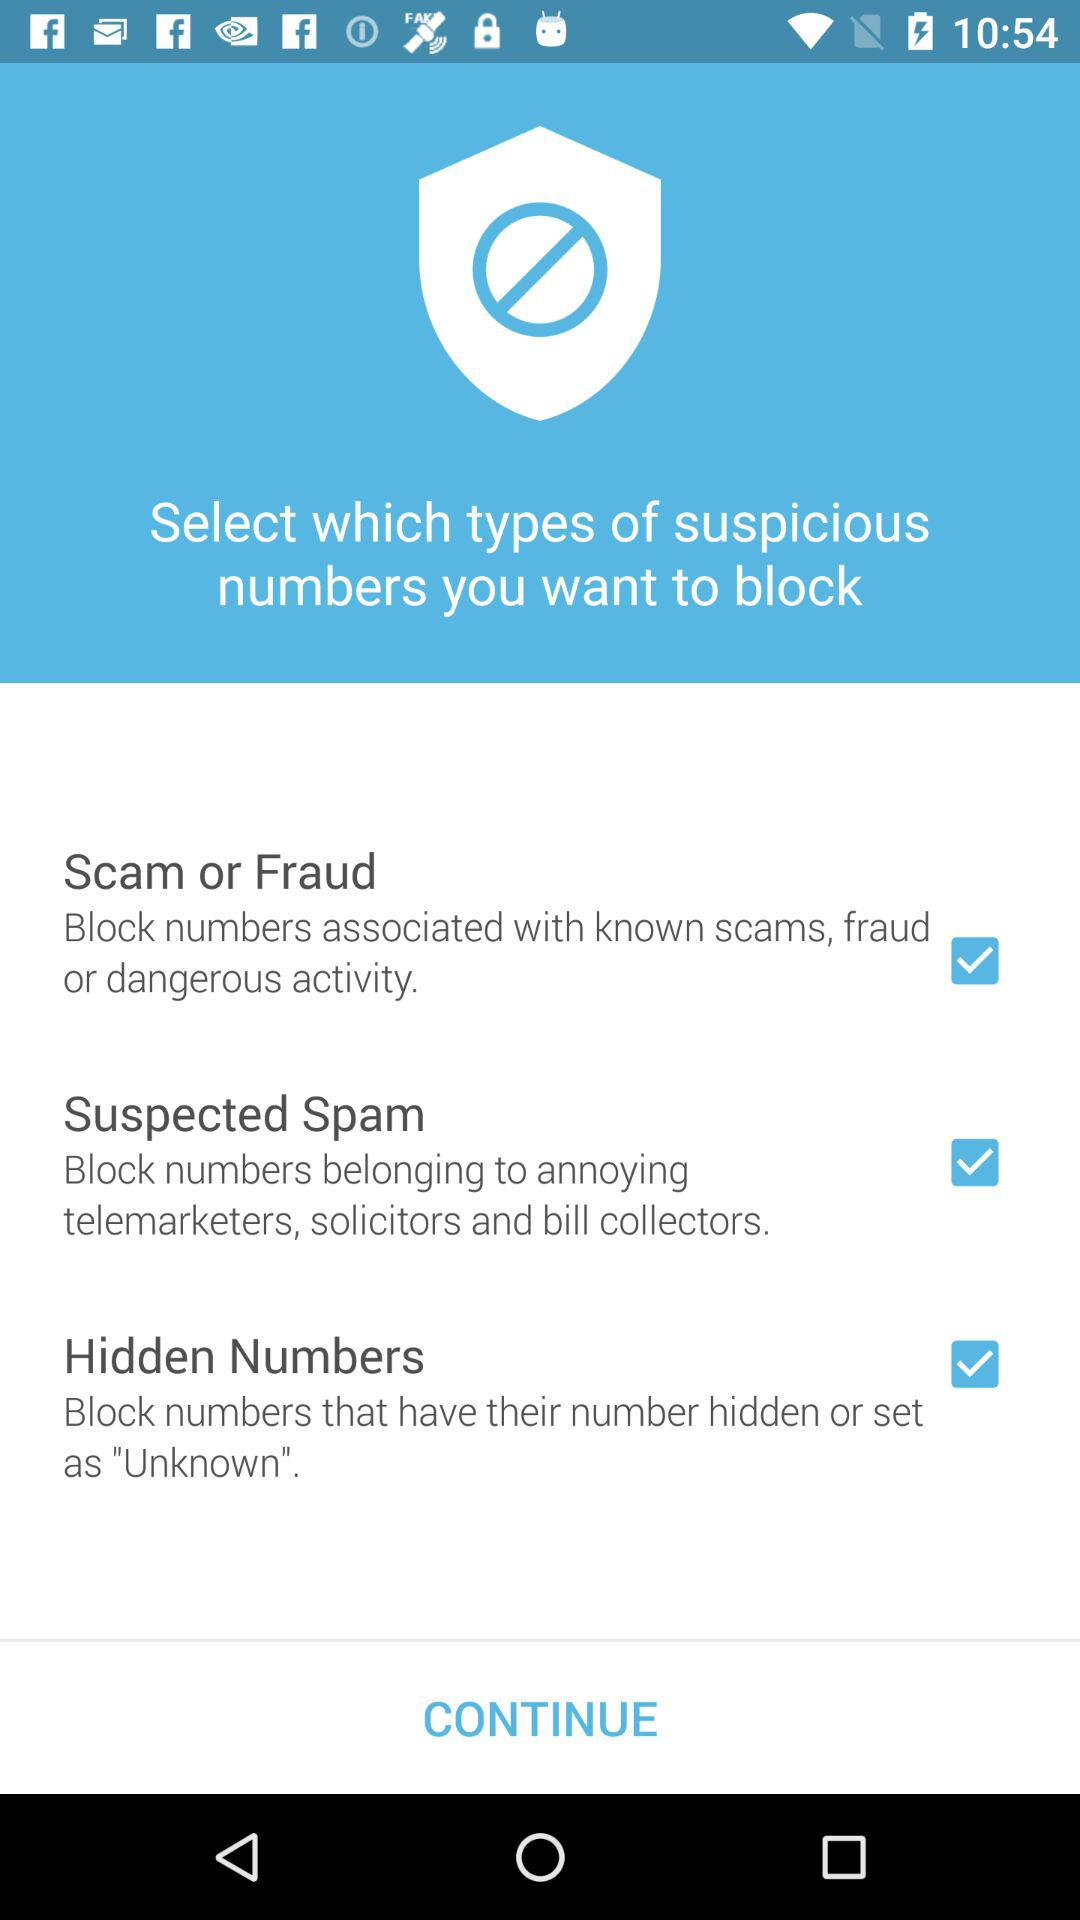How many types of suspicious numbers can I block?
Answer the question using a single word or phrase. 3 